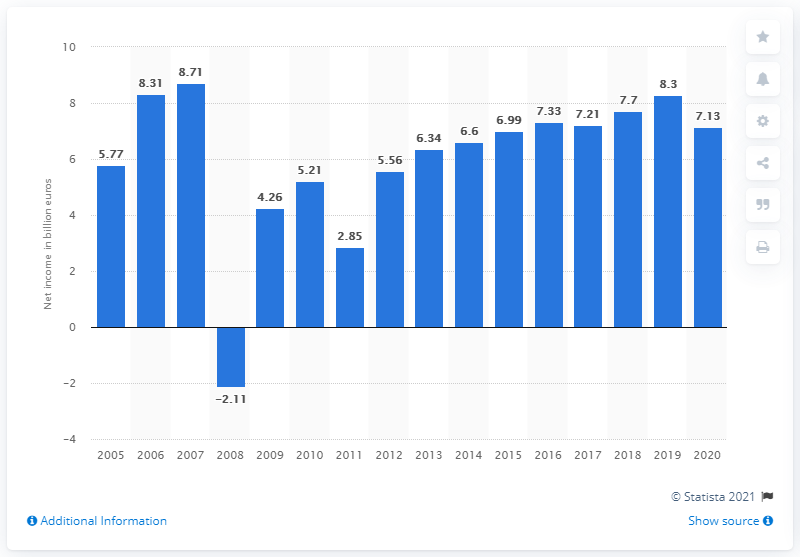Identify some key points in this picture. In 2005, the net income of the Allianz Group was 5.77 billion euros. In 2020, the net income of Allianz Group was 7.13. 